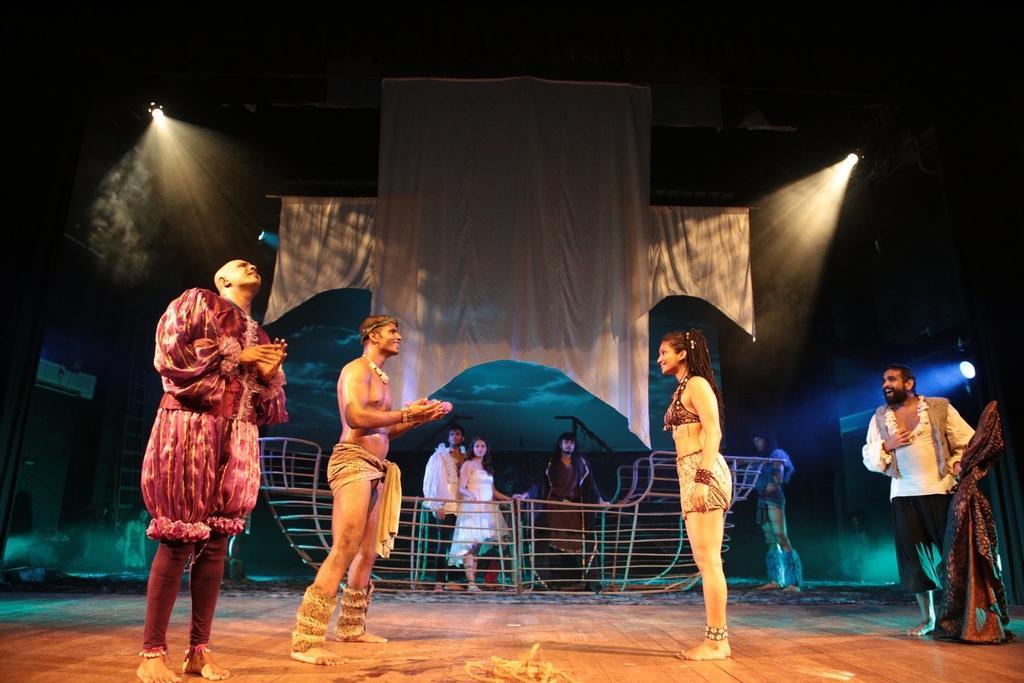Describe this image in one or two sentences. In this image we can see a group of people standing on the floor wearing the costumes. On the right side we can see a curtain. On the backside we can see a group of people standing beside a metal grill, a woman sitting on her knees on the floor, a ladder, the curtains and some lights. 